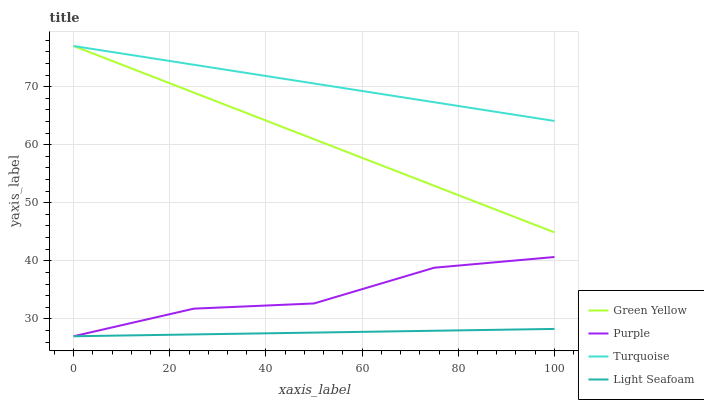Does Light Seafoam have the minimum area under the curve?
Answer yes or no. Yes. Does Turquoise have the maximum area under the curve?
Answer yes or no. Yes. Does Green Yellow have the minimum area under the curve?
Answer yes or no. No. Does Green Yellow have the maximum area under the curve?
Answer yes or no. No. Is Turquoise the smoothest?
Answer yes or no. Yes. Is Purple the roughest?
Answer yes or no. Yes. Is Green Yellow the smoothest?
Answer yes or no. No. Is Green Yellow the roughest?
Answer yes or no. No. Does Purple have the lowest value?
Answer yes or no. Yes. Does Green Yellow have the lowest value?
Answer yes or no. No. Does Green Yellow have the highest value?
Answer yes or no. Yes. Does Light Seafoam have the highest value?
Answer yes or no. No. Is Purple less than Turquoise?
Answer yes or no. Yes. Is Turquoise greater than Purple?
Answer yes or no. Yes. Does Light Seafoam intersect Purple?
Answer yes or no. Yes. Is Light Seafoam less than Purple?
Answer yes or no. No. Is Light Seafoam greater than Purple?
Answer yes or no. No. Does Purple intersect Turquoise?
Answer yes or no. No. 